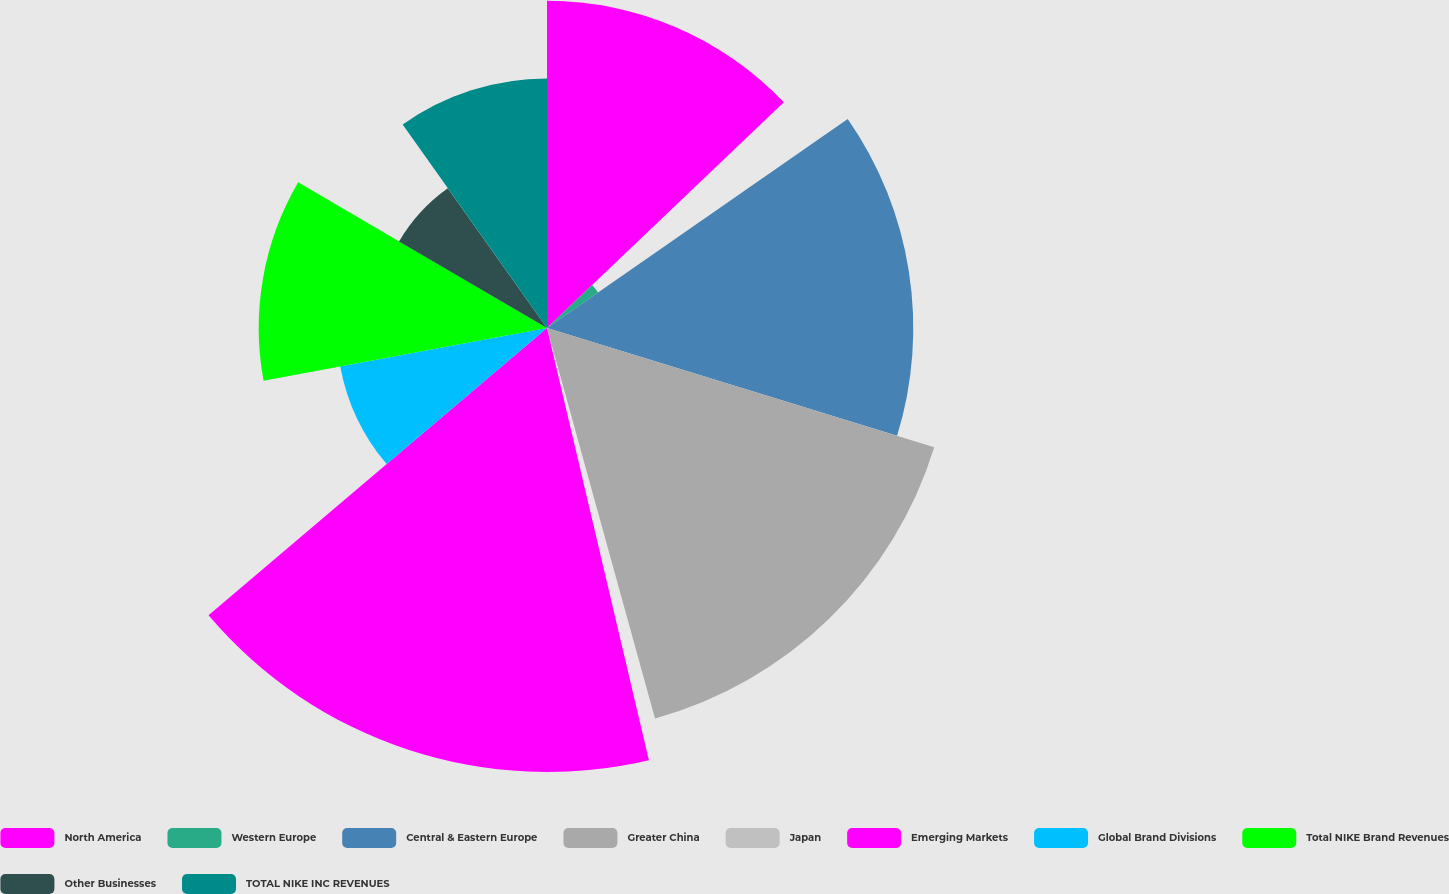<chart> <loc_0><loc_0><loc_500><loc_500><pie_chart><fcel>North America<fcel>Western Europe<fcel>Central & Eastern Europe<fcel>Greater China<fcel>Japan<fcel>Emerging Markets<fcel>Global Brand Divisions<fcel>Total NIKE Brand Revenues<fcel>Other Businesses<fcel>TOTAL NIKE INC REVENUES<nl><fcel>12.88%<fcel>2.45%<fcel>14.42%<fcel>15.95%<fcel>0.61%<fcel>17.48%<fcel>8.28%<fcel>11.35%<fcel>6.75%<fcel>9.82%<nl></chart> 